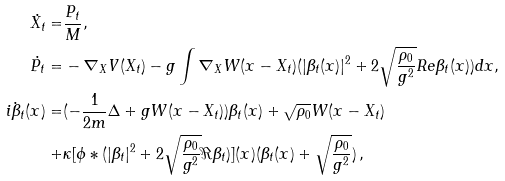Convert formula to latex. <formula><loc_0><loc_0><loc_500><loc_500>\dot { X _ { t } } = & \frac { P _ { t } } { M } , \quad \\ \dot { P _ { t } } = & - \nabla _ { X } V ( X _ { t } ) - g \int \nabla _ { X } W ( x - X _ { t } ) ( | \beta _ { t } ( x ) | ^ { 2 } + 2 \sqrt { \frac { \rho _ { 0 } } { g ^ { 2 } } } R e \beta _ { t } ( x ) ) d x , \\ i \dot { \beta } _ { t } ( x ) = & ( - \frac { 1 } { 2 m } \Delta + g W ( x - X _ { t } ) ) \beta _ { t } ( x ) + \sqrt { \rho _ { 0 } } W ( x - X _ { t } ) \\ + & \kappa [ \phi * ( | \beta _ { t } | ^ { 2 } + 2 \sqrt { \frac { \rho _ { 0 } } { g ^ { 2 } } } \Re \beta _ { t } ) ] ( x ) ( \beta _ { t } ( x ) + \sqrt { \frac { \rho _ { 0 } } { g ^ { 2 } } } ) \, ,</formula> 